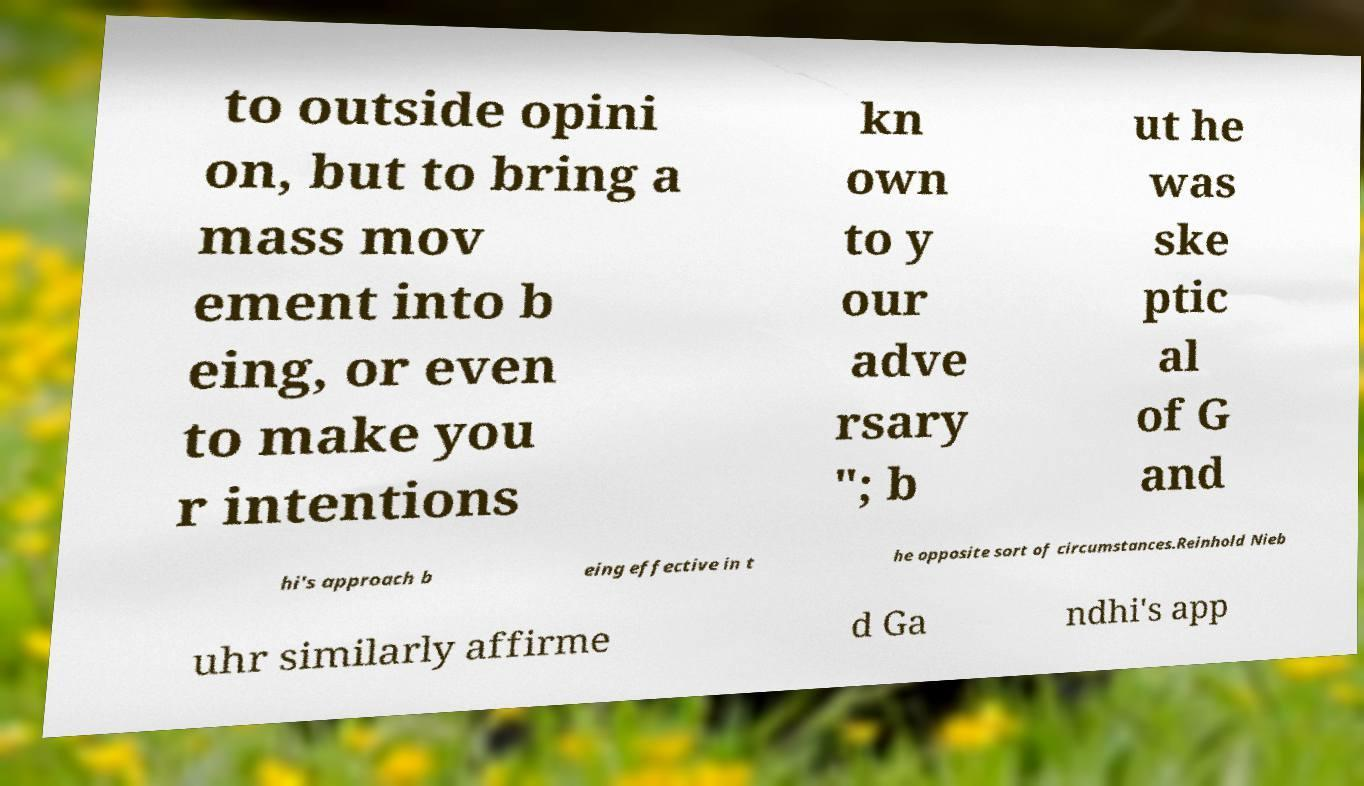Please identify and transcribe the text found in this image. to outside opini on, but to bring a mass mov ement into b eing, or even to make you r intentions kn own to y our adve rsary "; b ut he was ske ptic al of G and hi's approach b eing effective in t he opposite sort of circumstances.Reinhold Nieb uhr similarly affirme d Ga ndhi's app 